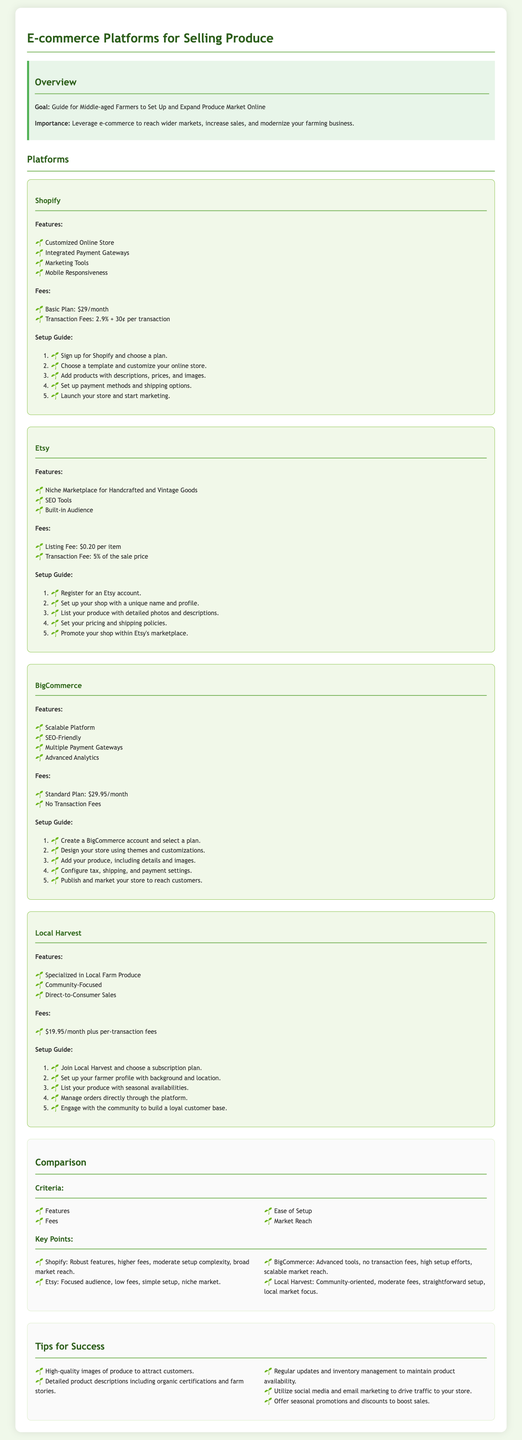what is the monthly fee for Shopify? The monthly fee for the Basic plan on Shopify is listed in the fees section.
Answer: $29 what are two key features of Etsy? The features of Etsy include details listed in the features section.
Answer: Niche Marketplace for Handcrafted and Vintage Goods, SEO Tools what is the listing fee for Etsy? The listing fee for each item on Etsy is mentioned in the fees section.
Answer: $0.20 which platform has no transaction fees? The platforms are compared in the comparison section, which highlights their fees.
Answer: BigCommerce how many steps are in the setup guide for Local Harvest? The setup guide for Local Harvest contains a specific number of steps outlined in an ordered list.
Answer: 5 what is one tip for success mentioned in the document? Tips for success are listed in the tips section as recommendations.
Answer: High-quality images of produce to attract customers which platform is described as community-focused? The description of features in the document identifies specific characteristics of each platform.
Answer: Local Harvest how often should you update your inventory according to the tips? The tip regarding inventory management is found in the tips section.
Answer: Regularly 